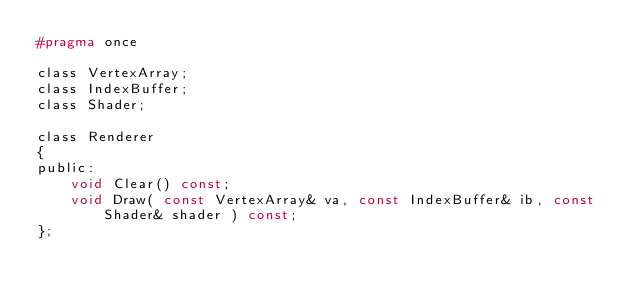<code> <loc_0><loc_0><loc_500><loc_500><_C_>#pragma once

class VertexArray;
class IndexBuffer;
class Shader;

class Renderer
{
public:
	void Clear() const;
	void Draw( const VertexArray& va, const IndexBuffer& ib, const Shader& shader ) const;
};
</code> 